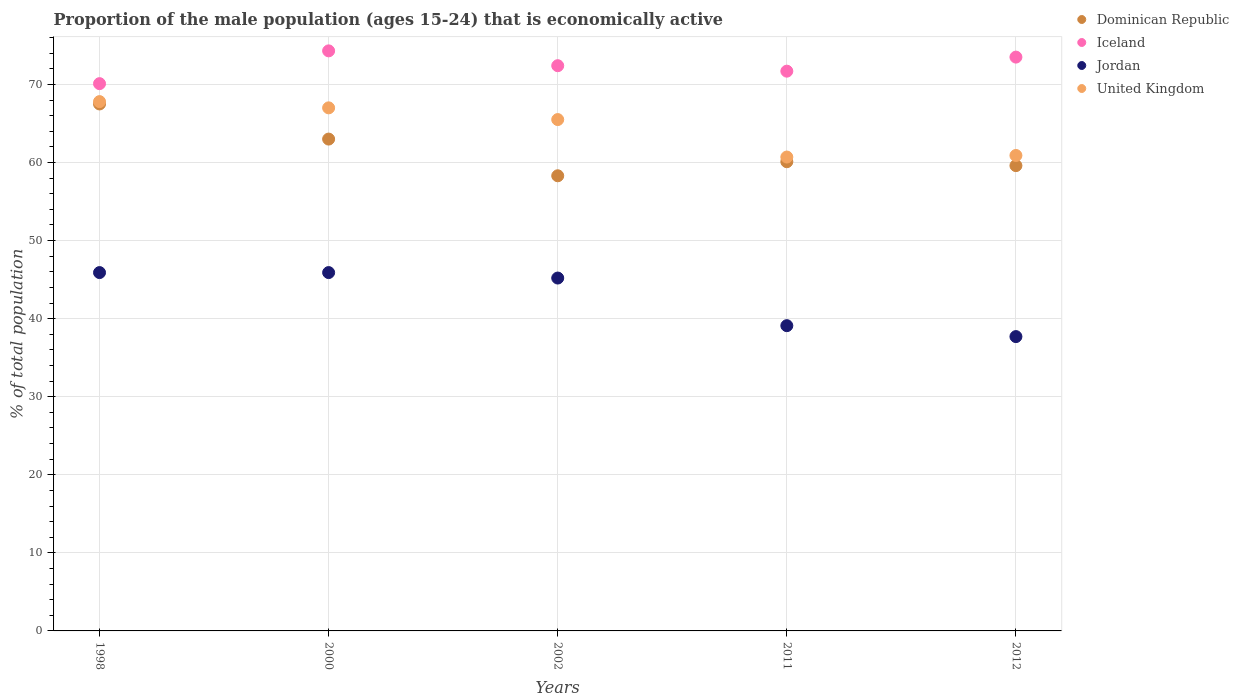Is the number of dotlines equal to the number of legend labels?
Your response must be concise. Yes. What is the proportion of the male population that is economically active in Iceland in 2012?
Provide a succinct answer. 73.5. Across all years, what is the maximum proportion of the male population that is economically active in Dominican Republic?
Offer a terse response. 67.5. Across all years, what is the minimum proportion of the male population that is economically active in Dominican Republic?
Provide a succinct answer. 58.3. In which year was the proportion of the male population that is economically active in Iceland maximum?
Offer a very short reply. 2000. What is the total proportion of the male population that is economically active in United Kingdom in the graph?
Keep it short and to the point. 321.9. What is the difference between the proportion of the male population that is economically active in Jordan in 2000 and that in 2011?
Offer a very short reply. 6.8. What is the difference between the proportion of the male population that is economically active in Jordan in 1998 and the proportion of the male population that is economically active in United Kingdom in 2002?
Offer a very short reply. -19.6. What is the average proportion of the male population that is economically active in Dominican Republic per year?
Offer a terse response. 61.7. In the year 2002, what is the difference between the proportion of the male population that is economically active in Jordan and proportion of the male population that is economically active in United Kingdom?
Keep it short and to the point. -20.3. In how many years, is the proportion of the male population that is economically active in United Kingdom greater than 56 %?
Provide a short and direct response. 5. What is the ratio of the proportion of the male population that is economically active in United Kingdom in 2000 to that in 2011?
Keep it short and to the point. 1.1. Is the difference between the proportion of the male population that is economically active in Jordan in 2011 and 2012 greater than the difference between the proportion of the male population that is economically active in United Kingdom in 2011 and 2012?
Your answer should be compact. Yes. What is the difference between the highest and the second highest proportion of the male population that is economically active in United Kingdom?
Make the answer very short. 0.8. What is the difference between the highest and the lowest proportion of the male population that is economically active in Jordan?
Offer a very short reply. 8.2. Is the sum of the proportion of the male population that is economically active in Jordan in 2002 and 2012 greater than the maximum proportion of the male population that is economically active in Iceland across all years?
Provide a succinct answer. Yes. Is it the case that in every year, the sum of the proportion of the male population that is economically active in Dominican Republic and proportion of the male population that is economically active in Jordan  is greater than the sum of proportion of the male population that is economically active in Iceland and proportion of the male population that is economically active in United Kingdom?
Offer a very short reply. No. Does the proportion of the male population that is economically active in Dominican Republic monotonically increase over the years?
Your answer should be compact. No. Is the proportion of the male population that is economically active in United Kingdom strictly greater than the proportion of the male population that is economically active in Jordan over the years?
Your answer should be compact. Yes. Is the proportion of the male population that is economically active in Dominican Republic strictly less than the proportion of the male population that is economically active in Jordan over the years?
Ensure brevity in your answer.  No. How many dotlines are there?
Offer a very short reply. 4. What is the difference between two consecutive major ticks on the Y-axis?
Give a very brief answer. 10. Are the values on the major ticks of Y-axis written in scientific E-notation?
Make the answer very short. No. Does the graph contain any zero values?
Keep it short and to the point. No. Where does the legend appear in the graph?
Make the answer very short. Top right. What is the title of the graph?
Your answer should be very brief. Proportion of the male population (ages 15-24) that is economically active. Does "Rwanda" appear as one of the legend labels in the graph?
Provide a short and direct response. No. What is the label or title of the Y-axis?
Your response must be concise. % of total population. What is the % of total population in Dominican Republic in 1998?
Your answer should be very brief. 67.5. What is the % of total population of Iceland in 1998?
Your response must be concise. 70.1. What is the % of total population of Jordan in 1998?
Provide a succinct answer. 45.9. What is the % of total population in United Kingdom in 1998?
Your response must be concise. 67.8. What is the % of total population of Dominican Republic in 2000?
Offer a very short reply. 63. What is the % of total population in Iceland in 2000?
Give a very brief answer. 74.3. What is the % of total population in Jordan in 2000?
Your response must be concise. 45.9. What is the % of total population in Dominican Republic in 2002?
Offer a terse response. 58.3. What is the % of total population of Iceland in 2002?
Provide a succinct answer. 72.4. What is the % of total population in Jordan in 2002?
Your answer should be compact. 45.2. What is the % of total population in United Kingdom in 2002?
Make the answer very short. 65.5. What is the % of total population in Dominican Republic in 2011?
Keep it short and to the point. 60.1. What is the % of total population in Iceland in 2011?
Offer a terse response. 71.7. What is the % of total population in Jordan in 2011?
Give a very brief answer. 39.1. What is the % of total population of United Kingdom in 2011?
Provide a short and direct response. 60.7. What is the % of total population in Dominican Republic in 2012?
Provide a short and direct response. 59.6. What is the % of total population in Iceland in 2012?
Offer a terse response. 73.5. What is the % of total population in Jordan in 2012?
Your answer should be very brief. 37.7. What is the % of total population in United Kingdom in 2012?
Offer a terse response. 60.9. Across all years, what is the maximum % of total population of Dominican Republic?
Your answer should be compact. 67.5. Across all years, what is the maximum % of total population of Iceland?
Your response must be concise. 74.3. Across all years, what is the maximum % of total population of Jordan?
Make the answer very short. 45.9. Across all years, what is the maximum % of total population of United Kingdom?
Give a very brief answer. 67.8. Across all years, what is the minimum % of total population in Dominican Republic?
Keep it short and to the point. 58.3. Across all years, what is the minimum % of total population of Iceland?
Your answer should be very brief. 70.1. Across all years, what is the minimum % of total population in Jordan?
Make the answer very short. 37.7. Across all years, what is the minimum % of total population of United Kingdom?
Ensure brevity in your answer.  60.7. What is the total % of total population of Dominican Republic in the graph?
Make the answer very short. 308.5. What is the total % of total population in Iceland in the graph?
Keep it short and to the point. 362. What is the total % of total population of Jordan in the graph?
Offer a very short reply. 213.8. What is the total % of total population of United Kingdom in the graph?
Your answer should be compact. 321.9. What is the difference between the % of total population of Dominican Republic in 1998 and that in 2000?
Give a very brief answer. 4.5. What is the difference between the % of total population of Jordan in 1998 and that in 2000?
Ensure brevity in your answer.  0. What is the difference between the % of total population of Iceland in 1998 and that in 2002?
Your answer should be very brief. -2.3. What is the difference between the % of total population of Jordan in 1998 and that in 2002?
Your answer should be very brief. 0.7. What is the difference between the % of total population in Jordan in 1998 and that in 2011?
Make the answer very short. 6.8. What is the difference between the % of total population in Dominican Republic in 1998 and that in 2012?
Your response must be concise. 7.9. What is the difference between the % of total population of United Kingdom in 2000 and that in 2002?
Offer a terse response. 1.5. What is the difference between the % of total population in United Kingdom in 2000 and that in 2011?
Keep it short and to the point. 6.3. What is the difference between the % of total population in Dominican Republic in 2000 and that in 2012?
Offer a very short reply. 3.4. What is the difference between the % of total population in Iceland in 2000 and that in 2012?
Offer a very short reply. 0.8. What is the difference between the % of total population in United Kingdom in 2000 and that in 2012?
Your answer should be compact. 6.1. What is the difference between the % of total population of Dominican Republic in 2002 and that in 2011?
Ensure brevity in your answer.  -1.8. What is the difference between the % of total population of Dominican Republic in 2002 and that in 2012?
Give a very brief answer. -1.3. What is the difference between the % of total population in Iceland in 2002 and that in 2012?
Offer a terse response. -1.1. What is the difference between the % of total population in Iceland in 2011 and that in 2012?
Make the answer very short. -1.8. What is the difference between the % of total population of United Kingdom in 2011 and that in 2012?
Your response must be concise. -0.2. What is the difference between the % of total population in Dominican Republic in 1998 and the % of total population in Iceland in 2000?
Keep it short and to the point. -6.8. What is the difference between the % of total population in Dominican Republic in 1998 and the % of total population in Jordan in 2000?
Provide a succinct answer. 21.6. What is the difference between the % of total population of Dominican Republic in 1998 and the % of total population of United Kingdom in 2000?
Offer a very short reply. 0.5. What is the difference between the % of total population of Iceland in 1998 and the % of total population of Jordan in 2000?
Offer a terse response. 24.2. What is the difference between the % of total population of Iceland in 1998 and the % of total population of United Kingdom in 2000?
Provide a succinct answer. 3.1. What is the difference between the % of total population in Jordan in 1998 and the % of total population in United Kingdom in 2000?
Your response must be concise. -21.1. What is the difference between the % of total population of Dominican Republic in 1998 and the % of total population of Jordan in 2002?
Ensure brevity in your answer.  22.3. What is the difference between the % of total population of Dominican Republic in 1998 and the % of total population of United Kingdom in 2002?
Offer a very short reply. 2. What is the difference between the % of total population of Iceland in 1998 and the % of total population of Jordan in 2002?
Make the answer very short. 24.9. What is the difference between the % of total population in Jordan in 1998 and the % of total population in United Kingdom in 2002?
Provide a succinct answer. -19.6. What is the difference between the % of total population in Dominican Republic in 1998 and the % of total population in Jordan in 2011?
Offer a terse response. 28.4. What is the difference between the % of total population in Dominican Republic in 1998 and the % of total population in United Kingdom in 2011?
Offer a terse response. 6.8. What is the difference between the % of total population of Jordan in 1998 and the % of total population of United Kingdom in 2011?
Offer a terse response. -14.8. What is the difference between the % of total population of Dominican Republic in 1998 and the % of total population of Iceland in 2012?
Give a very brief answer. -6. What is the difference between the % of total population in Dominican Republic in 1998 and the % of total population in Jordan in 2012?
Offer a terse response. 29.8. What is the difference between the % of total population of Iceland in 1998 and the % of total population of Jordan in 2012?
Keep it short and to the point. 32.4. What is the difference between the % of total population in Jordan in 1998 and the % of total population in United Kingdom in 2012?
Your answer should be very brief. -15. What is the difference between the % of total population of Dominican Republic in 2000 and the % of total population of Jordan in 2002?
Keep it short and to the point. 17.8. What is the difference between the % of total population of Iceland in 2000 and the % of total population of Jordan in 2002?
Provide a short and direct response. 29.1. What is the difference between the % of total population in Jordan in 2000 and the % of total population in United Kingdom in 2002?
Make the answer very short. -19.6. What is the difference between the % of total population in Dominican Republic in 2000 and the % of total population in Iceland in 2011?
Your answer should be very brief. -8.7. What is the difference between the % of total population of Dominican Republic in 2000 and the % of total population of Jordan in 2011?
Ensure brevity in your answer.  23.9. What is the difference between the % of total population in Iceland in 2000 and the % of total population in Jordan in 2011?
Give a very brief answer. 35.2. What is the difference between the % of total population in Jordan in 2000 and the % of total population in United Kingdom in 2011?
Ensure brevity in your answer.  -14.8. What is the difference between the % of total population of Dominican Republic in 2000 and the % of total population of Iceland in 2012?
Make the answer very short. -10.5. What is the difference between the % of total population of Dominican Republic in 2000 and the % of total population of Jordan in 2012?
Your answer should be very brief. 25.3. What is the difference between the % of total population of Iceland in 2000 and the % of total population of Jordan in 2012?
Provide a short and direct response. 36.6. What is the difference between the % of total population of Jordan in 2000 and the % of total population of United Kingdom in 2012?
Give a very brief answer. -15. What is the difference between the % of total population in Dominican Republic in 2002 and the % of total population in Iceland in 2011?
Your answer should be compact. -13.4. What is the difference between the % of total population in Iceland in 2002 and the % of total population in Jordan in 2011?
Make the answer very short. 33.3. What is the difference between the % of total population in Iceland in 2002 and the % of total population in United Kingdom in 2011?
Give a very brief answer. 11.7. What is the difference between the % of total population in Jordan in 2002 and the % of total population in United Kingdom in 2011?
Provide a short and direct response. -15.5. What is the difference between the % of total population of Dominican Republic in 2002 and the % of total population of Iceland in 2012?
Your response must be concise. -15.2. What is the difference between the % of total population in Dominican Republic in 2002 and the % of total population in Jordan in 2012?
Your response must be concise. 20.6. What is the difference between the % of total population of Dominican Republic in 2002 and the % of total population of United Kingdom in 2012?
Give a very brief answer. -2.6. What is the difference between the % of total population of Iceland in 2002 and the % of total population of Jordan in 2012?
Give a very brief answer. 34.7. What is the difference between the % of total population of Jordan in 2002 and the % of total population of United Kingdom in 2012?
Provide a succinct answer. -15.7. What is the difference between the % of total population in Dominican Republic in 2011 and the % of total population in Jordan in 2012?
Give a very brief answer. 22.4. What is the difference between the % of total population in Iceland in 2011 and the % of total population in Jordan in 2012?
Your answer should be very brief. 34. What is the difference between the % of total population in Iceland in 2011 and the % of total population in United Kingdom in 2012?
Your answer should be very brief. 10.8. What is the difference between the % of total population in Jordan in 2011 and the % of total population in United Kingdom in 2012?
Offer a very short reply. -21.8. What is the average % of total population of Dominican Republic per year?
Make the answer very short. 61.7. What is the average % of total population in Iceland per year?
Offer a very short reply. 72.4. What is the average % of total population of Jordan per year?
Your answer should be compact. 42.76. What is the average % of total population in United Kingdom per year?
Provide a succinct answer. 64.38. In the year 1998, what is the difference between the % of total population of Dominican Republic and % of total population of Jordan?
Your answer should be very brief. 21.6. In the year 1998, what is the difference between the % of total population in Dominican Republic and % of total population in United Kingdom?
Provide a short and direct response. -0.3. In the year 1998, what is the difference between the % of total population of Iceland and % of total population of Jordan?
Keep it short and to the point. 24.2. In the year 1998, what is the difference between the % of total population in Jordan and % of total population in United Kingdom?
Keep it short and to the point. -21.9. In the year 2000, what is the difference between the % of total population of Iceland and % of total population of Jordan?
Your answer should be very brief. 28.4. In the year 2000, what is the difference between the % of total population in Iceland and % of total population in United Kingdom?
Offer a very short reply. 7.3. In the year 2000, what is the difference between the % of total population in Jordan and % of total population in United Kingdom?
Offer a very short reply. -21.1. In the year 2002, what is the difference between the % of total population in Dominican Republic and % of total population in Iceland?
Offer a very short reply. -14.1. In the year 2002, what is the difference between the % of total population of Iceland and % of total population of Jordan?
Make the answer very short. 27.2. In the year 2002, what is the difference between the % of total population of Jordan and % of total population of United Kingdom?
Provide a short and direct response. -20.3. In the year 2011, what is the difference between the % of total population of Dominican Republic and % of total population of Jordan?
Provide a succinct answer. 21. In the year 2011, what is the difference between the % of total population in Iceland and % of total population in Jordan?
Provide a short and direct response. 32.6. In the year 2011, what is the difference between the % of total population of Jordan and % of total population of United Kingdom?
Give a very brief answer. -21.6. In the year 2012, what is the difference between the % of total population in Dominican Republic and % of total population in Jordan?
Your response must be concise. 21.9. In the year 2012, what is the difference between the % of total population of Dominican Republic and % of total population of United Kingdom?
Offer a terse response. -1.3. In the year 2012, what is the difference between the % of total population of Iceland and % of total population of Jordan?
Your answer should be compact. 35.8. In the year 2012, what is the difference between the % of total population of Iceland and % of total population of United Kingdom?
Your answer should be compact. 12.6. In the year 2012, what is the difference between the % of total population in Jordan and % of total population in United Kingdom?
Keep it short and to the point. -23.2. What is the ratio of the % of total population in Dominican Republic in 1998 to that in 2000?
Give a very brief answer. 1.07. What is the ratio of the % of total population of Iceland in 1998 to that in 2000?
Your answer should be compact. 0.94. What is the ratio of the % of total population of United Kingdom in 1998 to that in 2000?
Make the answer very short. 1.01. What is the ratio of the % of total population in Dominican Republic in 1998 to that in 2002?
Your answer should be compact. 1.16. What is the ratio of the % of total population of Iceland in 1998 to that in 2002?
Your answer should be very brief. 0.97. What is the ratio of the % of total population of Jordan in 1998 to that in 2002?
Ensure brevity in your answer.  1.02. What is the ratio of the % of total population in United Kingdom in 1998 to that in 2002?
Keep it short and to the point. 1.04. What is the ratio of the % of total population in Dominican Republic in 1998 to that in 2011?
Your answer should be very brief. 1.12. What is the ratio of the % of total population in Iceland in 1998 to that in 2011?
Offer a very short reply. 0.98. What is the ratio of the % of total population of Jordan in 1998 to that in 2011?
Your answer should be compact. 1.17. What is the ratio of the % of total population of United Kingdom in 1998 to that in 2011?
Offer a terse response. 1.12. What is the ratio of the % of total population in Dominican Republic in 1998 to that in 2012?
Give a very brief answer. 1.13. What is the ratio of the % of total population of Iceland in 1998 to that in 2012?
Ensure brevity in your answer.  0.95. What is the ratio of the % of total population in Jordan in 1998 to that in 2012?
Keep it short and to the point. 1.22. What is the ratio of the % of total population in United Kingdom in 1998 to that in 2012?
Your answer should be compact. 1.11. What is the ratio of the % of total population of Dominican Republic in 2000 to that in 2002?
Your response must be concise. 1.08. What is the ratio of the % of total population in Iceland in 2000 to that in 2002?
Your response must be concise. 1.03. What is the ratio of the % of total population in Jordan in 2000 to that in 2002?
Your answer should be compact. 1.02. What is the ratio of the % of total population in United Kingdom in 2000 to that in 2002?
Your response must be concise. 1.02. What is the ratio of the % of total population in Dominican Republic in 2000 to that in 2011?
Provide a short and direct response. 1.05. What is the ratio of the % of total population of Iceland in 2000 to that in 2011?
Your response must be concise. 1.04. What is the ratio of the % of total population of Jordan in 2000 to that in 2011?
Your answer should be compact. 1.17. What is the ratio of the % of total population in United Kingdom in 2000 to that in 2011?
Your answer should be very brief. 1.1. What is the ratio of the % of total population of Dominican Republic in 2000 to that in 2012?
Provide a succinct answer. 1.06. What is the ratio of the % of total population of Iceland in 2000 to that in 2012?
Give a very brief answer. 1.01. What is the ratio of the % of total population in Jordan in 2000 to that in 2012?
Give a very brief answer. 1.22. What is the ratio of the % of total population in United Kingdom in 2000 to that in 2012?
Provide a succinct answer. 1.1. What is the ratio of the % of total population of Dominican Republic in 2002 to that in 2011?
Make the answer very short. 0.97. What is the ratio of the % of total population of Iceland in 2002 to that in 2011?
Make the answer very short. 1.01. What is the ratio of the % of total population in Jordan in 2002 to that in 2011?
Give a very brief answer. 1.16. What is the ratio of the % of total population of United Kingdom in 2002 to that in 2011?
Provide a succinct answer. 1.08. What is the ratio of the % of total population in Dominican Republic in 2002 to that in 2012?
Offer a terse response. 0.98. What is the ratio of the % of total population in Jordan in 2002 to that in 2012?
Offer a very short reply. 1.2. What is the ratio of the % of total population in United Kingdom in 2002 to that in 2012?
Ensure brevity in your answer.  1.08. What is the ratio of the % of total population of Dominican Republic in 2011 to that in 2012?
Offer a terse response. 1.01. What is the ratio of the % of total population in Iceland in 2011 to that in 2012?
Provide a succinct answer. 0.98. What is the ratio of the % of total population in Jordan in 2011 to that in 2012?
Your response must be concise. 1.04. What is the difference between the highest and the lowest % of total population of Jordan?
Your answer should be very brief. 8.2. 